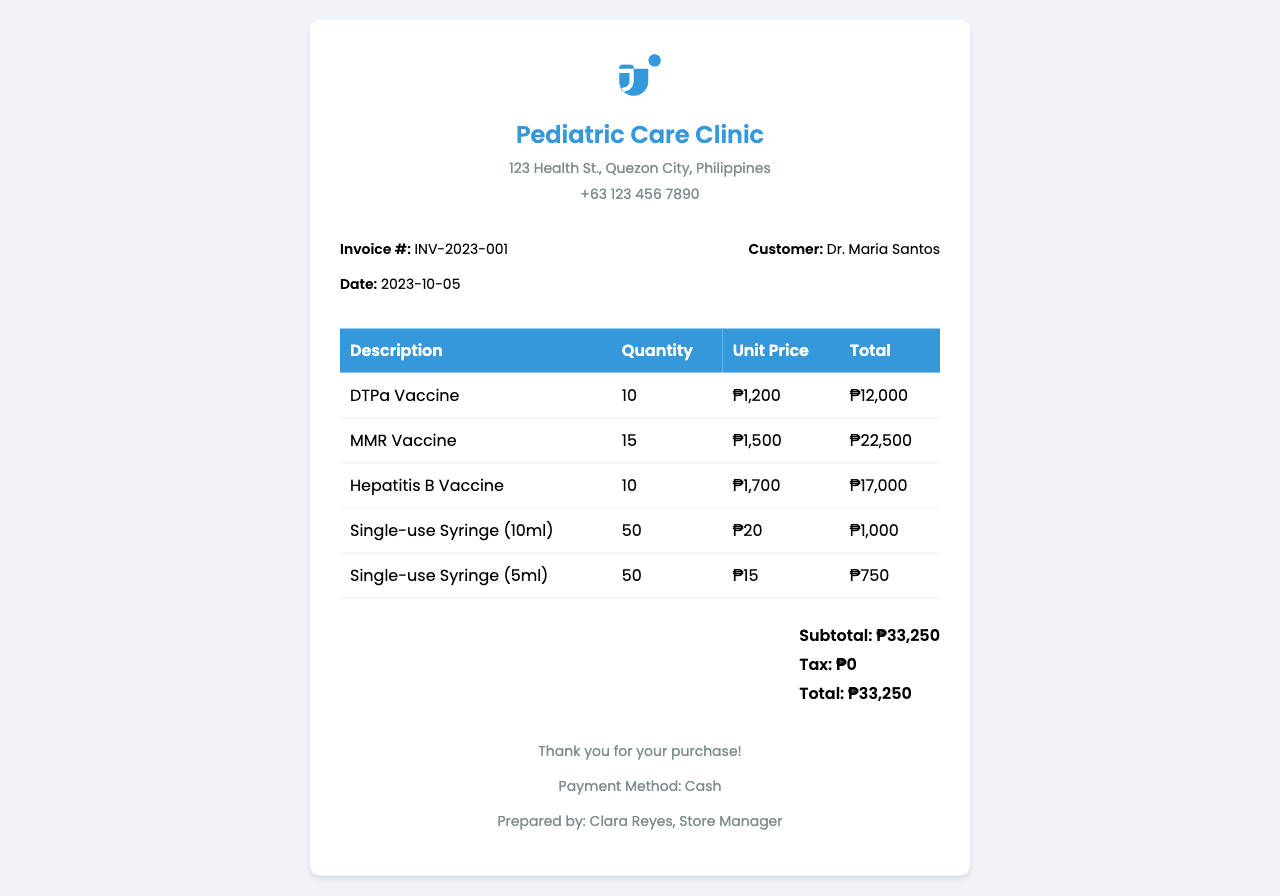What is the invoice number? The invoice number is listed under the invoice details section of the document.
Answer: INV-2023-001 Who prepared the receipt? The name of the person who prepared the receipt is mentioned in the footer.
Answer: Clara Reyes What is the date of the invoice? The date is provided in the invoice details section.
Answer: 2023-10-05 How many DTPa vaccines were purchased? The quantity of DTPa vaccines is specified in the items table.
Answer: 10 What is the subtotal amount? The subtotal is noted in the summary section of the receipt.
Answer: ₱33,250 What is the total amount due? The total amount is listed in the summary section and is the same as the subtotal.
Answer: ₱33,250 How many single-use syringes of 5ml were ordered? The quantity is indicated in the items table under the syringe description.
Answer: 50 What medical supply has the highest unit price? The item with the highest unit price can be determined by comparing the unit prices in the table.
Answer: MMR Vaccine What payment method was used for this purchase? The payment method is specified in the footer of the document.
Answer: Cash 